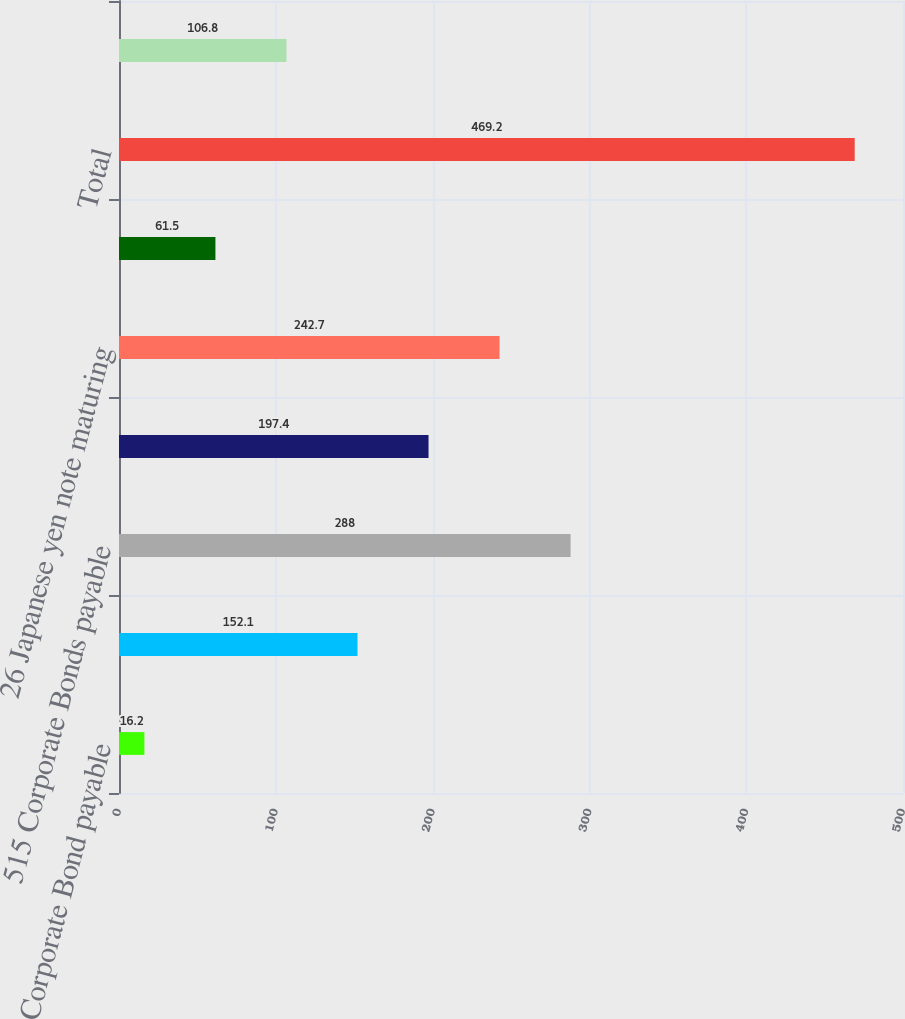<chart> <loc_0><loc_0><loc_500><loc_500><bar_chart><fcel>54 Corporate Bond payable<fcel>47 Corporate Bond payable<fcel>515 Corporate Bonds payable<fcel>15 Japanese yen note payable<fcel>26 Japanese yen note maturing<fcel>20 Japanese yen note maturing<fcel>Total<fcel>Less current maturities<nl><fcel>16.2<fcel>152.1<fcel>288<fcel>197.4<fcel>242.7<fcel>61.5<fcel>469.2<fcel>106.8<nl></chart> 